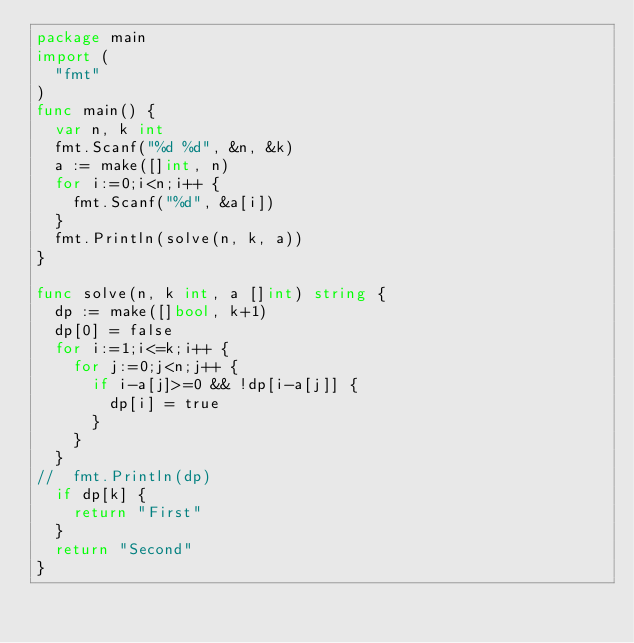Convert code to text. <code><loc_0><loc_0><loc_500><loc_500><_Go_>package main
import (
  "fmt"
)
func main() {
  var n, k int
  fmt.Scanf("%d %d", &n, &k)
  a := make([]int, n)
  for i:=0;i<n;i++ {
    fmt.Scanf("%d", &a[i])
  }
  fmt.Println(solve(n, k, a))
}

func solve(n, k int, a []int) string {
  dp := make([]bool, k+1)
  dp[0] = false
  for i:=1;i<=k;i++ {
    for j:=0;j<n;j++ {
      if i-a[j]>=0 && !dp[i-a[j]] {
        dp[i] = true
      }
    }
  }
//  fmt.Println(dp)
  if dp[k] {
    return "First"
  }
  return "Second"
}</code> 